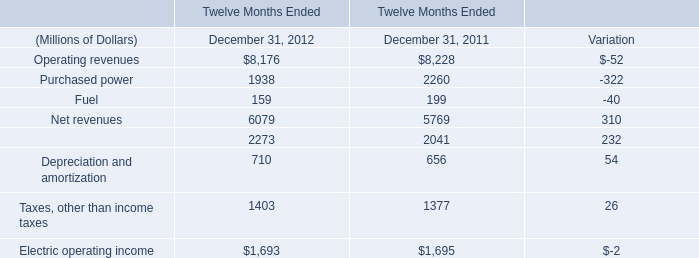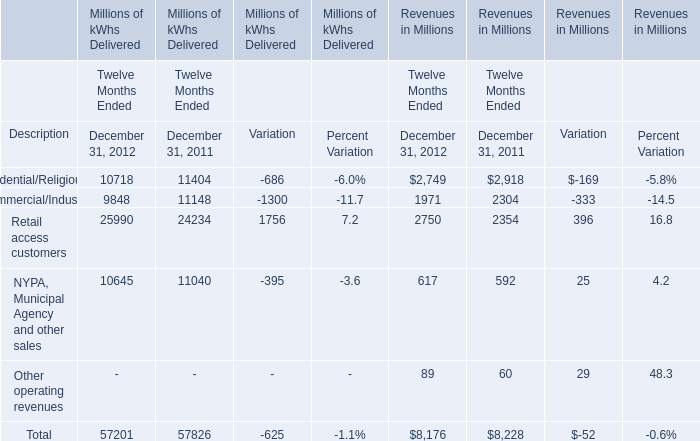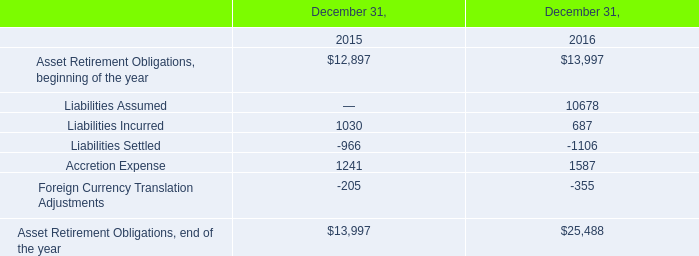In what year is Operating revenues greater than 8000? 
Answer: 2011 2012. 